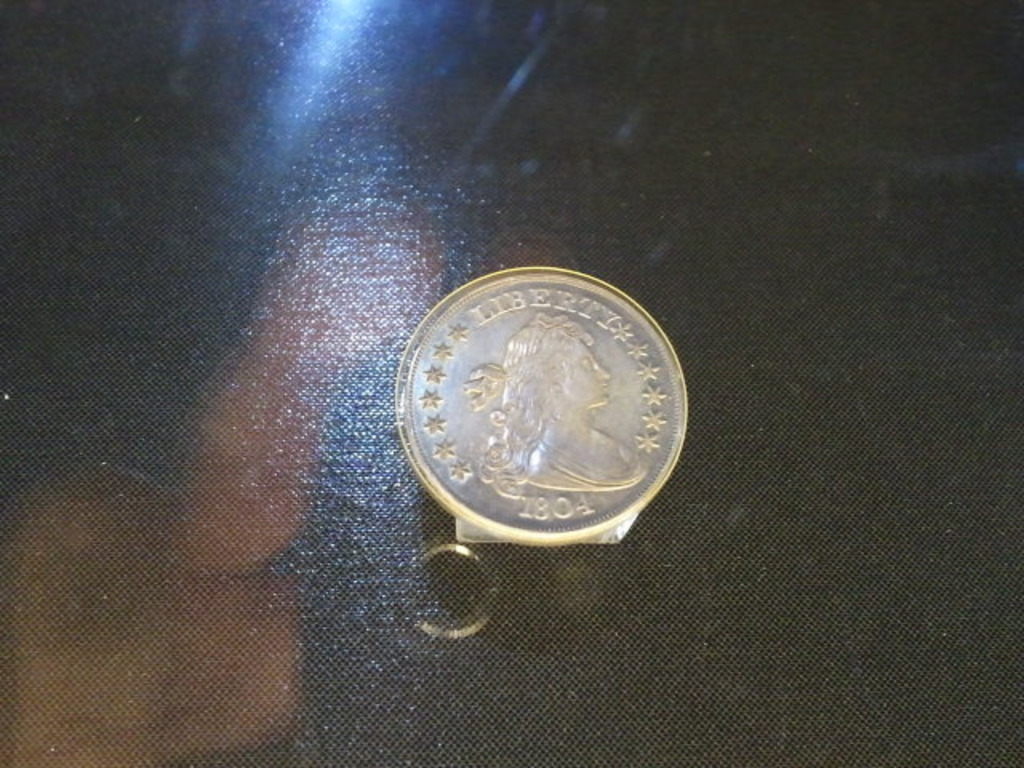How do collectors ensure the authenticity of a coin? Collectors use a few methods to ensure the authenticity of a coin. These include examining diagnostic details under magnification, consulting expert numismatists, and getting a coin graded by professional services like PCGS or NGC which also encapsulate the coin in tamper-evident holders. Additionally, collectors look at the historical documentation and sometimes use scientific tests to verify the metal composition. 